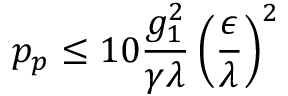<formula> <loc_0><loc_0><loc_500><loc_500>p _ { p } \leq 1 0 \frac { g _ { 1 } ^ { 2 } } { \gamma \lambda } \left ( \frac { \epsilon } { \lambda } \right ) ^ { 2 }</formula> 